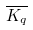<formula> <loc_0><loc_0><loc_500><loc_500>\overline { K _ { q } }</formula> 